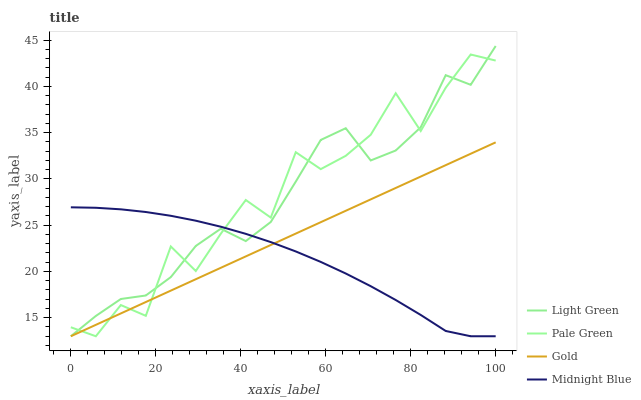Does Midnight Blue have the minimum area under the curve?
Answer yes or no. Yes. Does Pale Green have the maximum area under the curve?
Answer yes or no. Yes. Does Gold have the minimum area under the curve?
Answer yes or no. No. Does Gold have the maximum area under the curve?
Answer yes or no. No. Is Gold the smoothest?
Answer yes or no. Yes. Is Pale Green the roughest?
Answer yes or no. Yes. Is Light Green the smoothest?
Answer yes or no. No. Is Light Green the roughest?
Answer yes or no. No. Does Pale Green have the lowest value?
Answer yes or no. Yes. Does Light Green have the highest value?
Answer yes or no. Yes. Does Gold have the highest value?
Answer yes or no. No. Does Pale Green intersect Midnight Blue?
Answer yes or no. Yes. Is Pale Green less than Midnight Blue?
Answer yes or no. No. Is Pale Green greater than Midnight Blue?
Answer yes or no. No. 